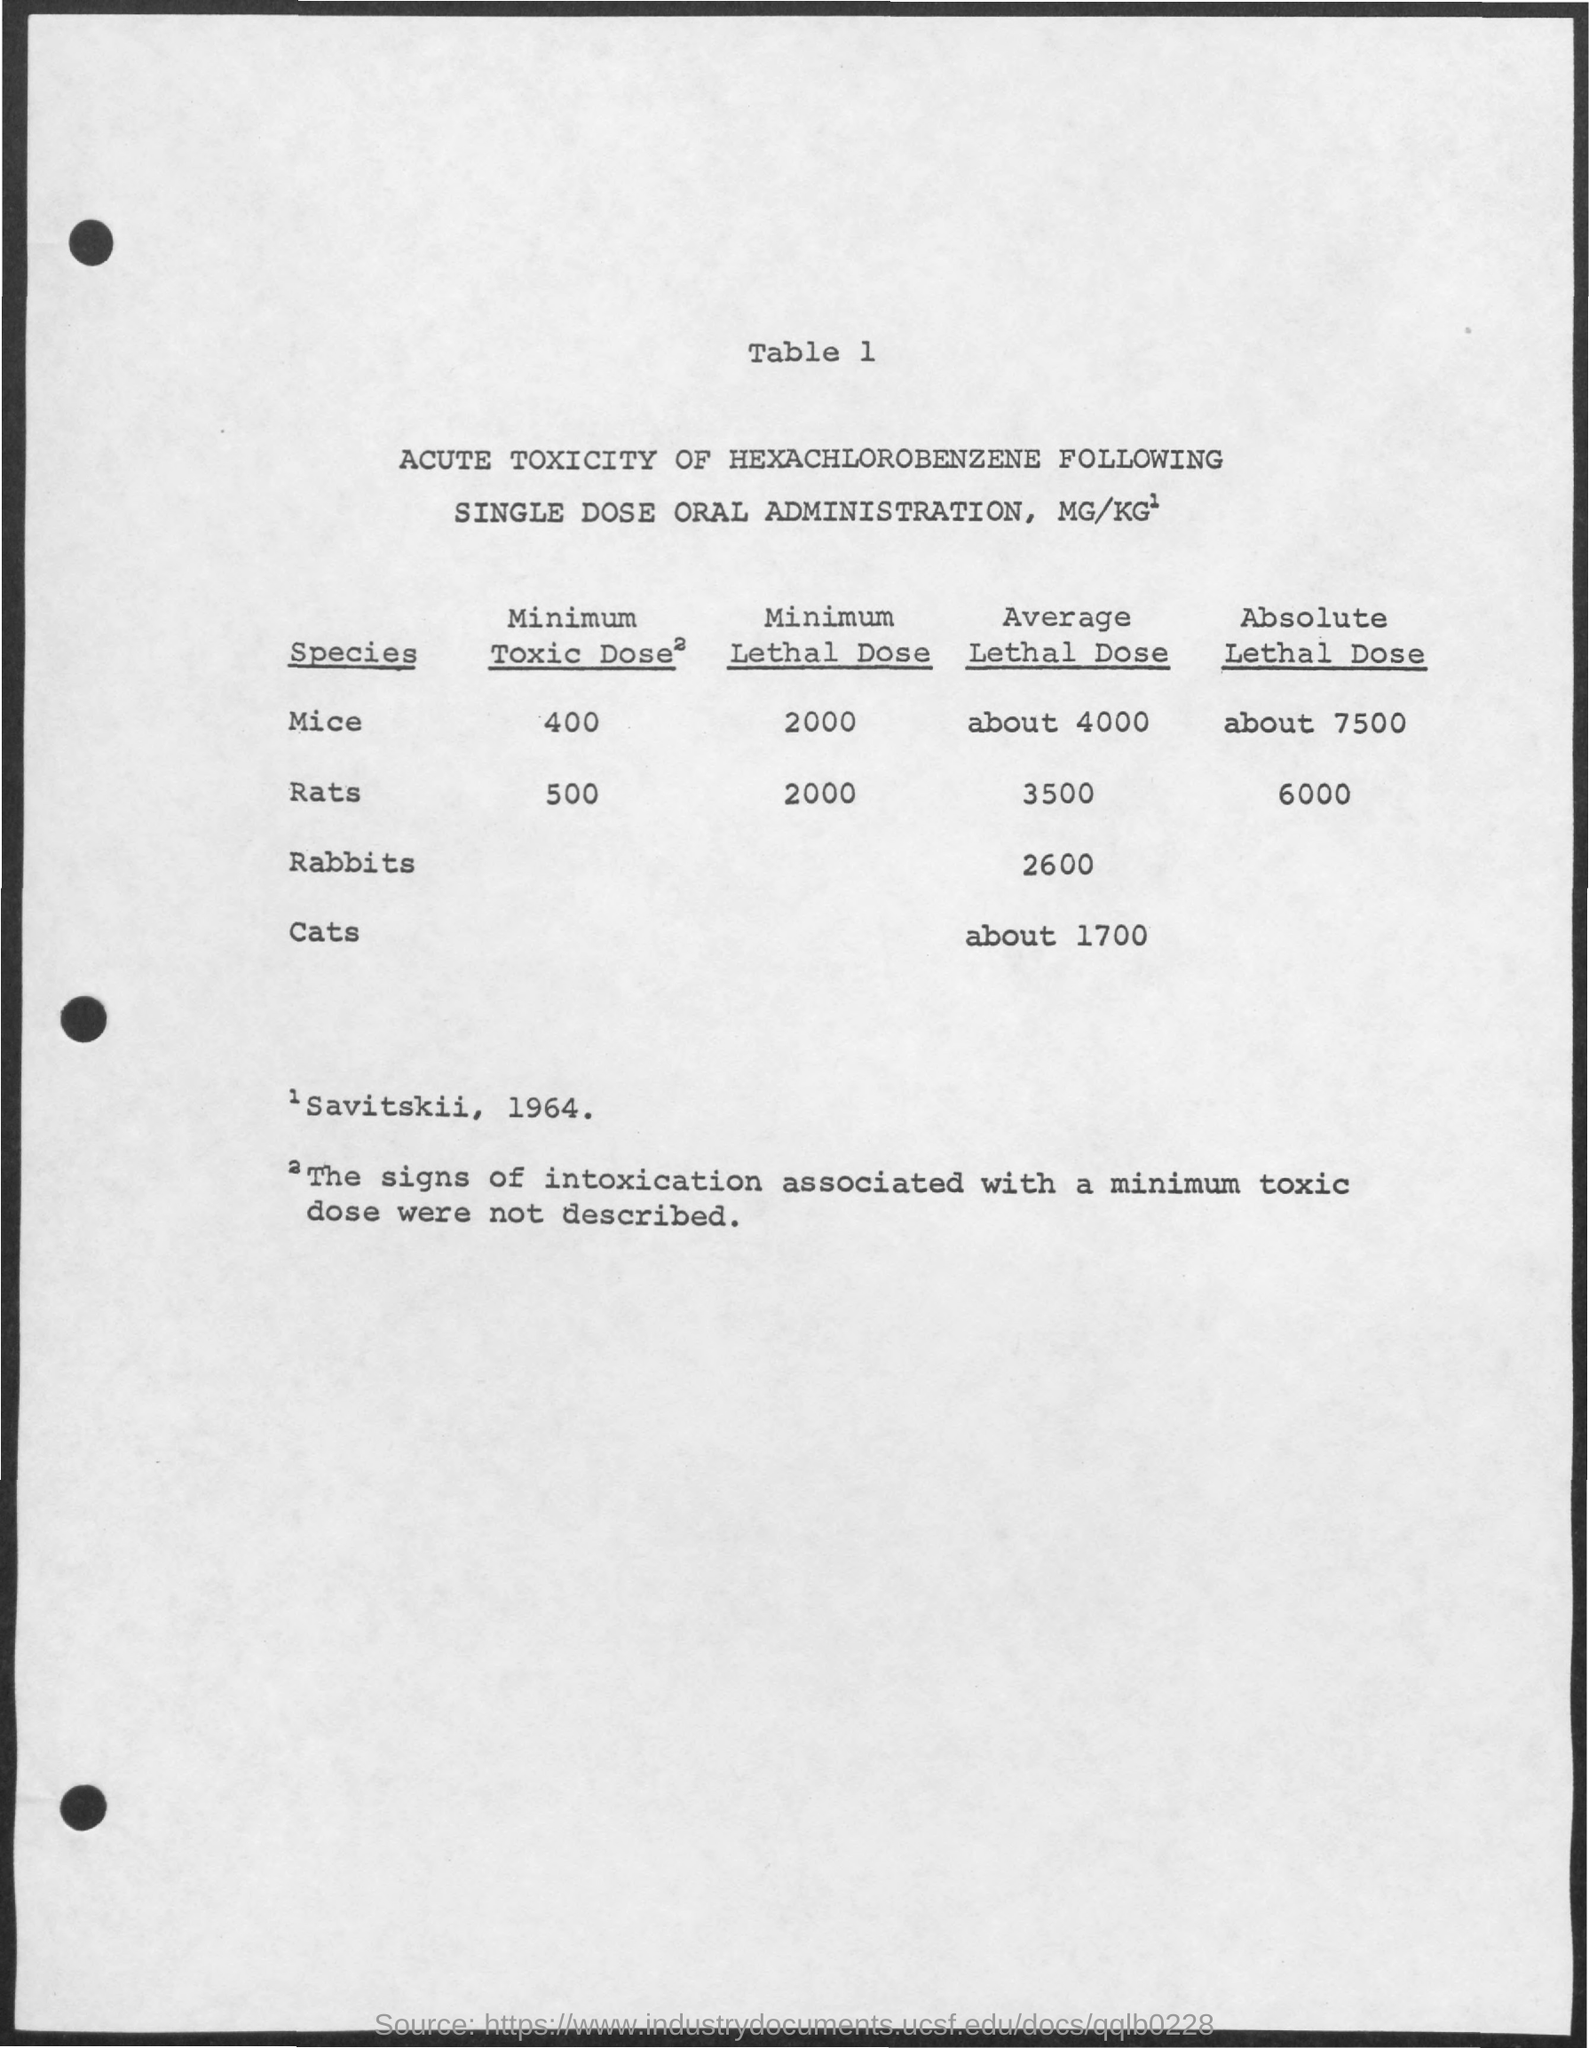Highlight a few significant elements in this photo. The species that has provided the highest average lethal dose is mice. The minimum toxic dose for mice is 400. According to Table 1, the average lethal dose for cats is approximately 1700. The species that has provided the highest absolute lethal dose is mice. The minimum lethal dose for mice has been reported to be 2000 milligrams per kilogram of body weight. 